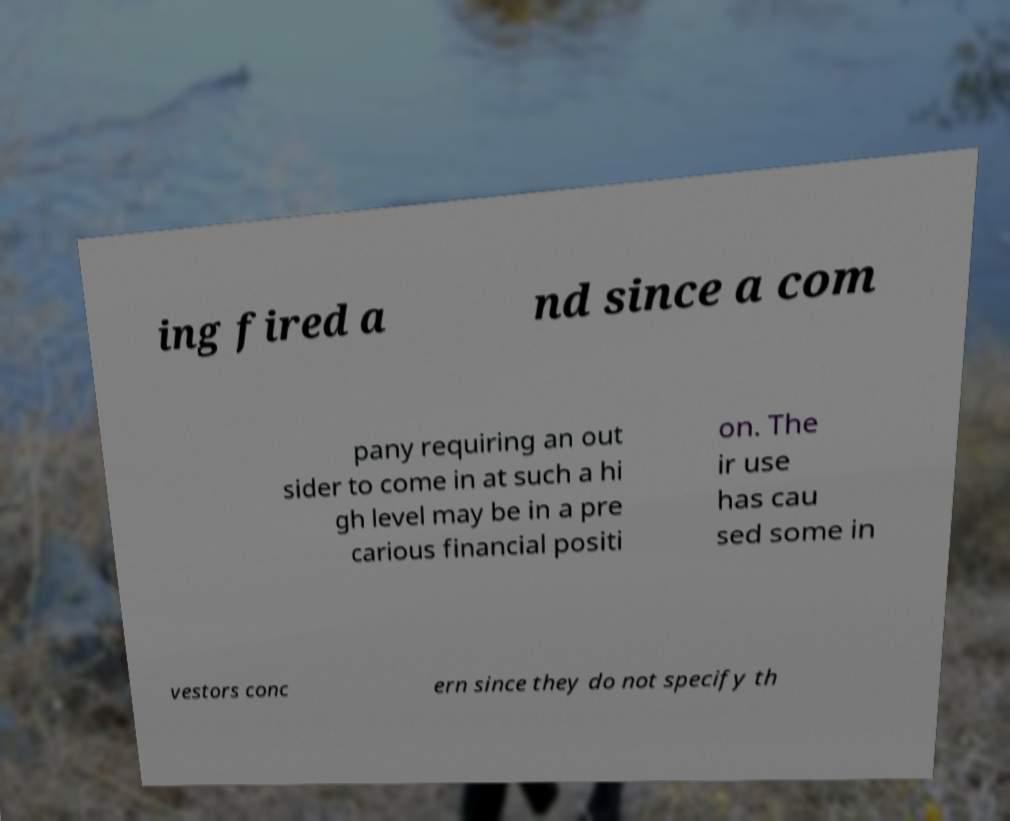What messages or text are displayed in this image? I need them in a readable, typed format. ing fired a nd since a com pany requiring an out sider to come in at such a hi gh level may be in a pre carious financial positi on. The ir use has cau sed some in vestors conc ern since they do not specify th 